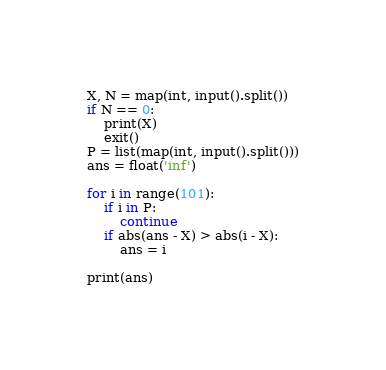<code> <loc_0><loc_0><loc_500><loc_500><_Python_>X, N = map(int, input().split())
if N == 0:
    print(X)
    exit()
P = list(map(int, input().split()))
ans = float('inf')

for i in range(101):
    if i in P:
        continue
    if abs(ans - X) > abs(i - X):
        ans = i

print(ans)</code> 